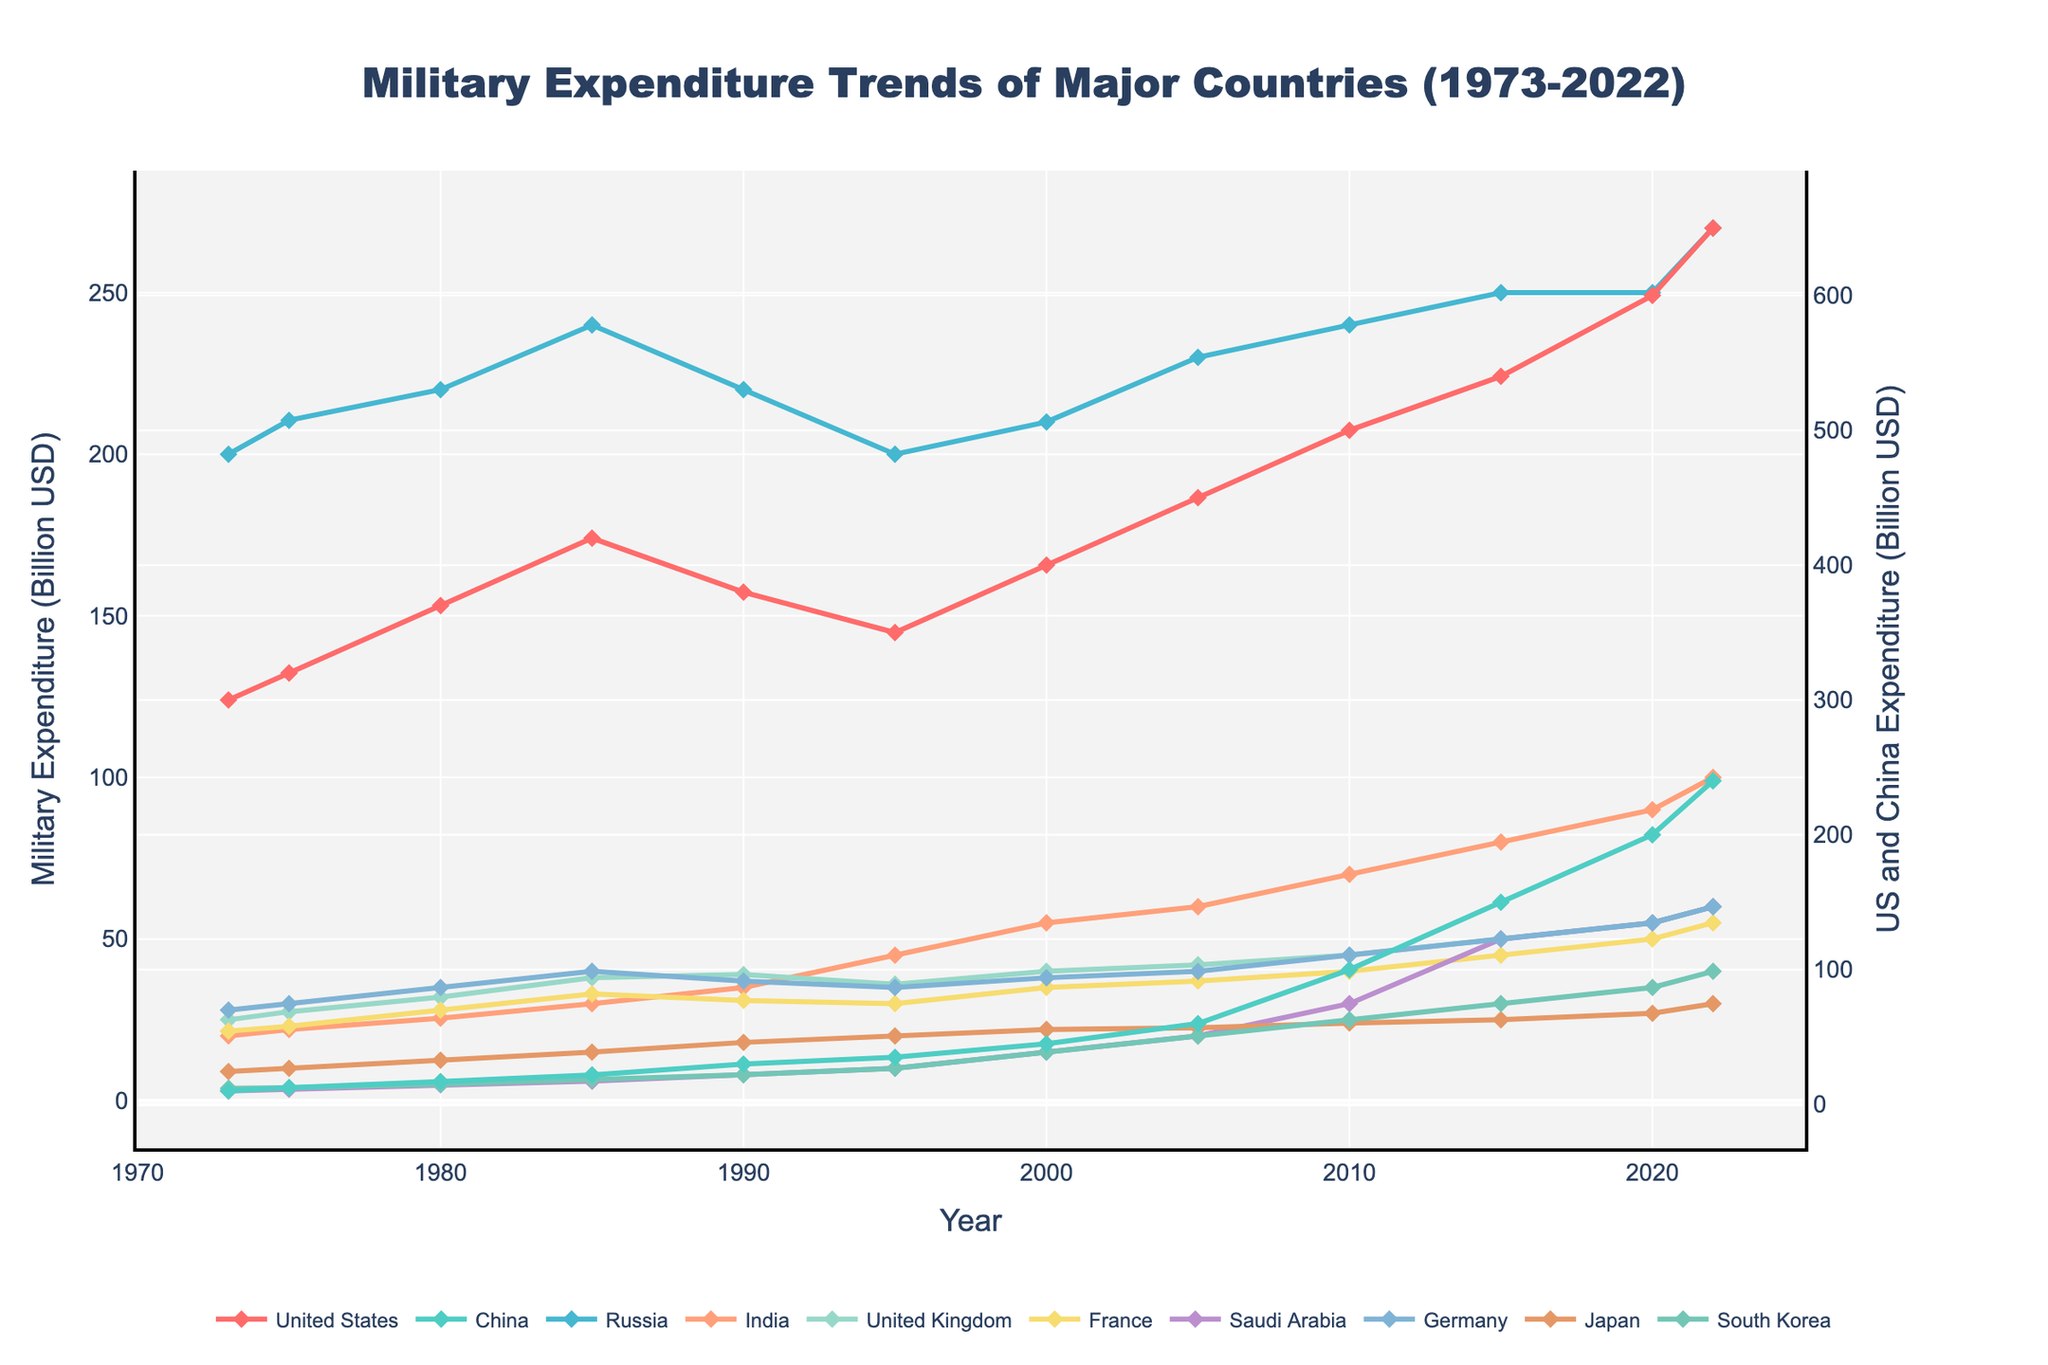What is the title of the plot? The title is typically displayed at the top of the plot and describes what the plot is about. In this case, it is "Military Expenditure Trends of Major Countries (1973-2022)."
Answer: Military Expenditure Trends of Major Countries (1973-2022) Which country has the highest military expenditure consistently over the years? By examining the trends in the plot, the United States' expenditure line is consistently higher than those of the other countries throughout the 50 years.
Answer: United States How has China's military expenditure changed from 1973 to 2022? To find this, look at the beginning and end points of China's line on the time series plot. In 1973, it starts at 10.1 billion USD and increases to 240 billion USD by 2022.
Answer: Increased from 10.1 billion USD to 240 billion USD Between which years did Saudi Arabia's military expenditure experience the most significant increase? Look for the steepest slope in Saudi Arabia's line on the plot. The period from 2005 to 2022 shows a sharp increase in military expenditure.
Answer: 2005 to 2022 Compare the trend in military expenditure of Russia and India between 1990 and 2000. To compare, look for the changes in the lines of Russia and India between these years. Russia's expenditure slightly decreased from 220 billion USD to 210 billion USD while India's increased from 35 billion USD to 55 billion USD.
Answer: Russia's expenditure slightly decreased, India's increased What is the trend of military expenditure for the United Kingdom over the 50 years? Analyze the plotted line for the United Kingdom from 1973 to 2022. It shows fluctuating expenditures but a general upward trend from 25 billion USD to 60 billion USD.
Answer: General upward trend During which decade did Japan's military expenditure grow the most, and by how much? Observe Japan's line on the plot and identify the decade with the most significant slope. From 1980 to 1990, Japan's expenditure grew from 12.5 billion USD to 18 billion USD, a 5.5 billion USD increase.
Answer: 1980 to 1990, increased by 5.5 billion USD Which country had the lowest military expenditure in 2022, and what was the amount? Find the lowest point on the expenditure lines in the year 2022. Japan has the lowest expenditure at 30 billion USD.
Answer: Japan, 30 billion USD Calculate the average military expenditure for France over the 50 years. To determine the average, sum the expenditure values for France at each recorded year and divide by the number of years (11). The values are 21.5, 23.0, 28.0, 33.0, 31.0, 30.0, 35.0, 37.0, 40.0, 45.0, and 55.0. Sum is 378.5 and average is 378.5/11.
Answer: 34.4 billion USD 